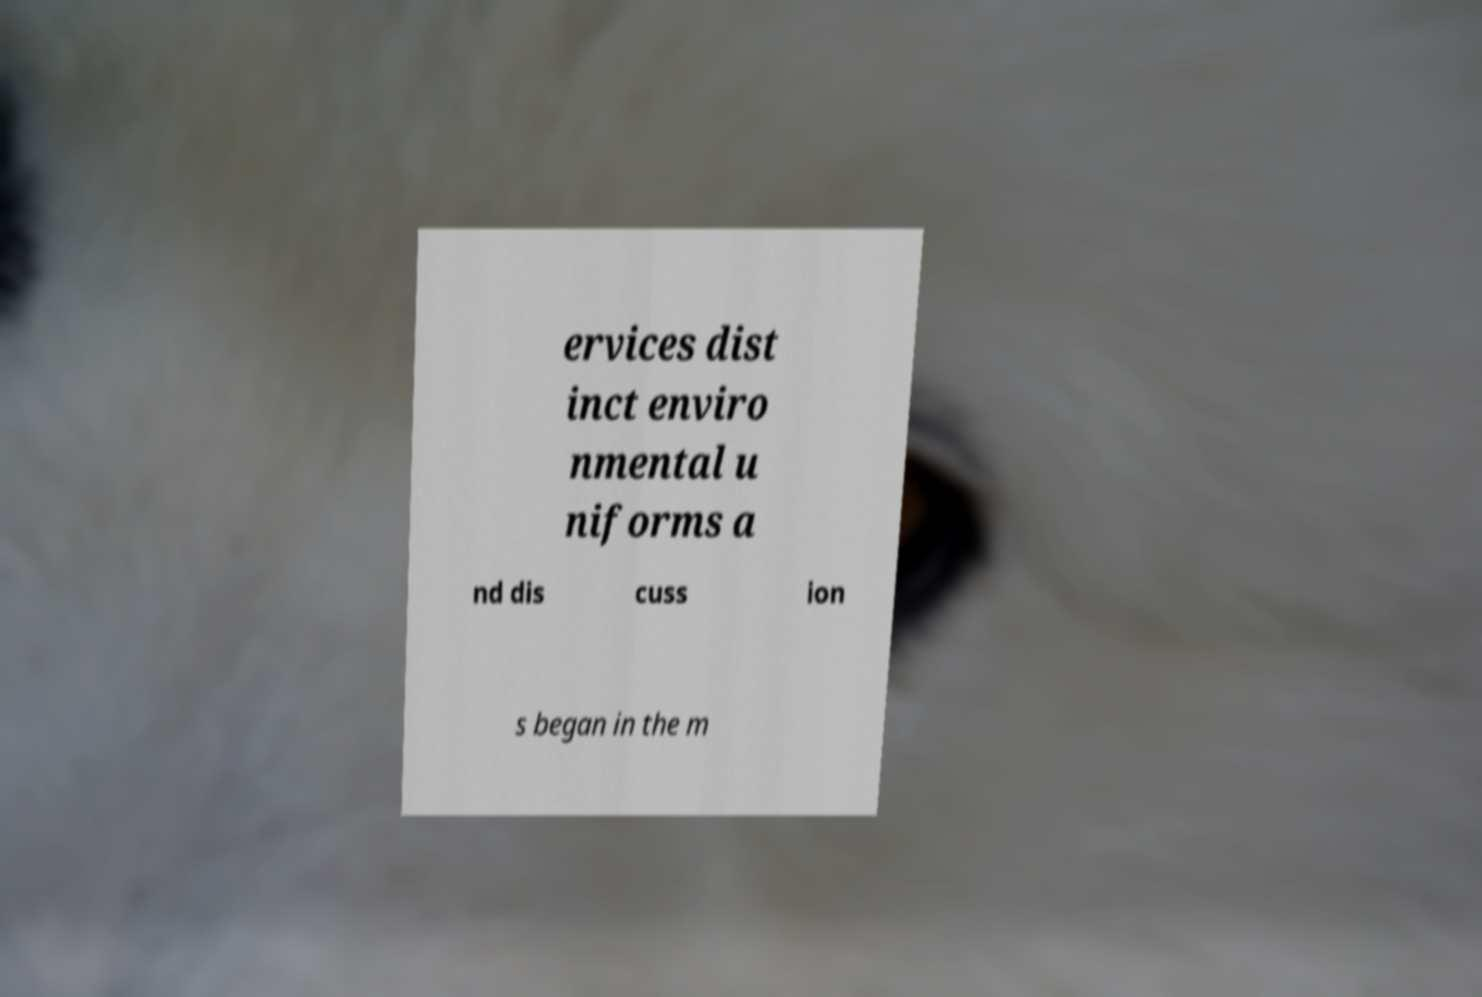Can you read and provide the text displayed in the image?This photo seems to have some interesting text. Can you extract and type it out for me? ervices dist inct enviro nmental u niforms a nd dis cuss ion s began in the m 